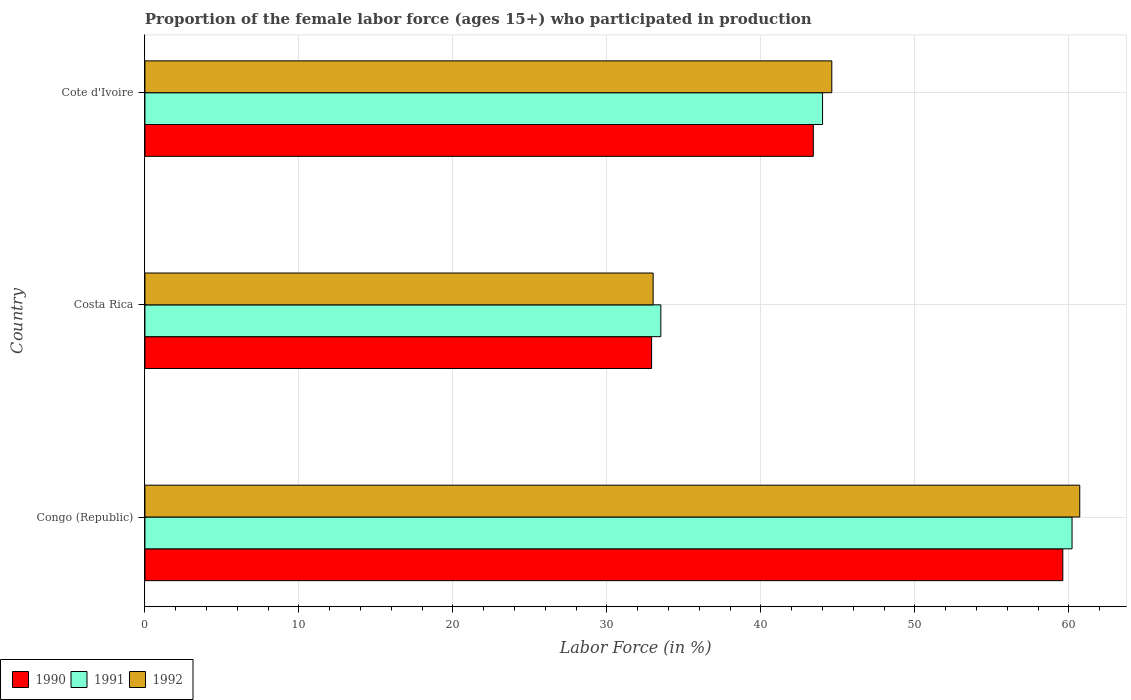How many different coloured bars are there?
Make the answer very short. 3. How many groups of bars are there?
Offer a terse response. 3. How many bars are there on the 2nd tick from the top?
Ensure brevity in your answer.  3. How many bars are there on the 1st tick from the bottom?
Give a very brief answer. 3. What is the label of the 1st group of bars from the top?
Ensure brevity in your answer.  Cote d'Ivoire. In how many cases, is the number of bars for a given country not equal to the number of legend labels?
Your answer should be very brief. 0. What is the proportion of the female labor force who participated in production in 1990 in Congo (Republic)?
Ensure brevity in your answer.  59.6. Across all countries, what is the maximum proportion of the female labor force who participated in production in 1990?
Your response must be concise. 59.6. Across all countries, what is the minimum proportion of the female labor force who participated in production in 1990?
Give a very brief answer. 32.9. In which country was the proportion of the female labor force who participated in production in 1990 maximum?
Make the answer very short. Congo (Republic). What is the total proportion of the female labor force who participated in production in 1990 in the graph?
Provide a succinct answer. 135.9. What is the difference between the proportion of the female labor force who participated in production in 1990 in Costa Rica and that in Cote d'Ivoire?
Your answer should be very brief. -10.5. What is the difference between the proportion of the female labor force who participated in production in 1991 in Cote d'Ivoire and the proportion of the female labor force who participated in production in 1992 in Costa Rica?
Your response must be concise. 11. What is the average proportion of the female labor force who participated in production in 1991 per country?
Your answer should be very brief. 45.9. What is the difference between the proportion of the female labor force who participated in production in 1992 and proportion of the female labor force who participated in production in 1991 in Cote d'Ivoire?
Provide a succinct answer. 0.6. In how many countries, is the proportion of the female labor force who participated in production in 1991 greater than 30 %?
Ensure brevity in your answer.  3. What is the ratio of the proportion of the female labor force who participated in production in 1990 in Costa Rica to that in Cote d'Ivoire?
Make the answer very short. 0.76. Is the difference between the proportion of the female labor force who participated in production in 1992 in Congo (Republic) and Cote d'Ivoire greater than the difference between the proportion of the female labor force who participated in production in 1991 in Congo (Republic) and Cote d'Ivoire?
Keep it short and to the point. No. What is the difference between the highest and the second highest proportion of the female labor force who participated in production in 1990?
Your answer should be compact. 16.2. What is the difference between the highest and the lowest proportion of the female labor force who participated in production in 1990?
Provide a short and direct response. 26.7. In how many countries, is the proportion of the female labor force who participated in production in 1990 greater than the average proportion of the female labor force who participated in production in 1990 taken over all countries?
Offer a very short reply. 1. Is the sum of the proportion of the female labor force who participated in production in 1990 in Congo (Republic) and Cote d'Ivoire greater than the maximum proportion of the female labor force who participated in production in 1992 across all countries?
Make the answer very short. Yes. What does the 2nd bar from the top in Costa Rica represents?
Your response must be concise. 1991. What does the 2nd bar from the bottom in Cote d'Ivoire represents?
Give a very brief answer. 1991. How many bars are there?
Offer a terse response. 9. Does the graph contain any zero values?
Offer a very short reply. No. Does the graph contain grids?
Give a very brief answer. Yes. Where does the legend appear in the graph?
Your answer should be very brief. Bottom left. How many legend labels are there?
Your answer should be compact. 3. How are the legend labels stacked?
Provide a succinct answer. Horizontal. What is the title of the graph?
Offer a very short reply. Proportion of the female labor force (ages 15+) who participated in production. Does "1970" appear as one of the legend labels in the graph?
Give a very brief answer. No. What is the label or title of the X-axis?
Make the answer very short. Labor Force (in %). What is the Labor Force (in %) of 1990 in Congo (Republic)?
Your answer should be very brief. 59.6. What is the Labor Force (in %) in 1991 in Congo (Republic)?
Offer a very short reply. 60.2. What is the Labor Force (in %) in 1992 in Congo (Republic)?
Provide a succinct answer. 60.7. What is the Labor Force (in %) in 1990 in Costa Rica?
Keep it short and to the point. 32.9. What is the Labor Force (in %) of 1991 in Costa Rica?
Offer a terse response. 33.5. What is the Labor Force (in %) in 1990 in Cote d'Ivoire?
Give a very brief answer. 43.4. What is the Labor Force (in %) in 1991 in Cote d'Ivoire?
Provide a succinct answer. 44. What is the Labor Force (in %) of 1992 in Cote d'Ivoire?
Give a very brief answer. 44.6. Across all countries, what is the maximum Labor Force (in %) in 1990?
Offer a terse response. 59.6. Across all countries, what is the maximum Labor Force (in %) in 1991?
Your answer should be very brief. 60.2. Across all countries, what is the maximum Labor Force (in %) in 1992?
Provide a succinct answer. 60.7. Across all countries, what is the minimum Labor Force (in %) in 1990?
Ensure brevity in your answer.  32.9. Across all countries, what is the minimum Labor Force (in %) of 1991?
Give a very brief answer. 33.5. Across all countries, what is the minimum Labor Force (in %) of 1992?
Make the answer very short. 33. What is the total Labor Force (in %) of 1990 in the graph?
Your answer should be compact. 135.9. What is the total Labor Force (in %) in 1991 in the graph?
Your answer should be very brief. 137.7. What is the total Labor Force (in %) of 1992 in the graph?
Ensure brevity in your answer.  138.3. What is the difference between the Labor Force (in %) in 1990 in Congo (Republic) and that in Costa Rica?
Give a very brief answer. 26.7. What is the difference between the Labor Force (in %) of 1991 in Congo (Republic) and that in Costa Rica?
Ensure brevity in your answer.  26.7. What is the difference between the Labor Force (in %) in 1992 in Congo (Republic) and that in Costa Rica?
Your answer should be very brief. 27.7. What is the difference between the Labor Force (in %) in 1990 in Congo (Republic) and that in Cote d'Ivoire?
Provide a short and direct response. 16.2. What is the difference between the Labor Force (in %) of 1992 in Congo (Republic) and that in Cote d'Ivoire?
Offer a terse response. 16.1. What is the difference between the Labor Force (in %) of 1990 in Costa Rica and that in Cote d'Ivoire?
Provide a succinct answer. -10.5. What is the difference between the Labor Force (in %) in 1992 in Costa Rica and that in Cote d'Ivoire?
Offer a terse response. -11.6. What is the difference between the Labor Force (in %) in 1990 in Congo (Republic) and the Labor Force (in %) in 1991 in Costa Rica?
Provide a short and direct response. 26.1. What is the difference between the Labor Force (in %) in 1990 in Congo (Republic) and the Labor Force (in %) in 1992 in Costa Rica?
Make the answer very short. 26.6. What is the difference between the Labor Force (in %) of 1991 in Congo (Republic) and the Labor Force (in %) of 1992 in Costa Rica?
Give a very brief answer. 27.2. What is the difference between the Labor Force (in %) in 1991 in Congo (Republic) and the Labor Force (in %) in 1992 in Cote d'Ivoire?
Make the answer very short. 15.6. What is the difference between the Labor Force (in %) of 1990 in Costa Rica and the Labor Force (in %) of 1991 in Cote d'Ivoire?
Give a very brief answer. -11.1. What is the difference between the Labor Force (in %) of 1991 in Costa Rica and the Labor Force (in %) of 1992 in Cote d'Ivoire?
Your response must be concise. -11.1. What is the average Labor Force (in %) of 1990 per country?
Provide a succinct answer. 45.3. What is the average Labor Force (in %) in 1991 per country?
Keep it short and to the point. 45.9. What is the average Labor Force (in %) of 1992 per country?
Ensure brevity in your answer.  46.1. What is the difference between the Labor Force (in %) in 1990 and Labor Force (in %) in 1992 in Congo (Republic)?
Give a very brief answer. -1.1. What is the ratio of the Labor Force (in %) of 1990 in Congo (Republic) to that in Costa Rica?
Your response must be concise. 1.81. What is the ratio of the Labor Force (in %) of 1991 in Congo (Republic) to that in Costa Rica?
Provide a succinct answer. 1.8. What is the ratio of the Labor Force (in %) of 1992 in Congo (Republic) to that in Costa Rica?
Offer a very short reply. 1.84. What is the ratio of the Labor Force (in %) in 1990 in Congo (Republic) to that in Cote d'Ivoire?
Provide a succinct answer. 1.37. What is the ratio of the Labor Force (in %) in 1991 in Congo (Republic) to that in Cote d'Ivoire?
Your response must be concise. 1.37. What is the ratio of the Labor Force (in %) of 1992 in Congo (Republic) to that in Cote d'Ivoire?
Ensure brevity in your answer.  1.36. What is the ratio of the Labor Force (in %) of 1990 in Costa Rica to that in Cote d'Ivoire?
Keep it short and to the point. 0.76. What is the ratio of the Labor Force (in %) in 1991 in Costa Rica to that in Cote d'Ivoire?
Your answer should be compact. 0.76. What is the ratio of the Labor Force (in %) of 1992 in Costa Rica to that in Cote d'Ivoire?
Keep it short and to the point. 0.74. What is the difference between the highest and the second highest Labor Force (in %) of 1990?
Provide a succinct answer. 16.2. What is the difference between the highest and the lowest Labor Force (in %) of 1990?
Ensure brevity in your answer.  26.7. What is the difference between the highest and the lowest Labor Force (in %) of 1991?
Provide a short and direct response. 26.7. What is the difference between the highest and the lowest Labor Force (in %) of 1992?
Give a very brief answer. 27.7. 